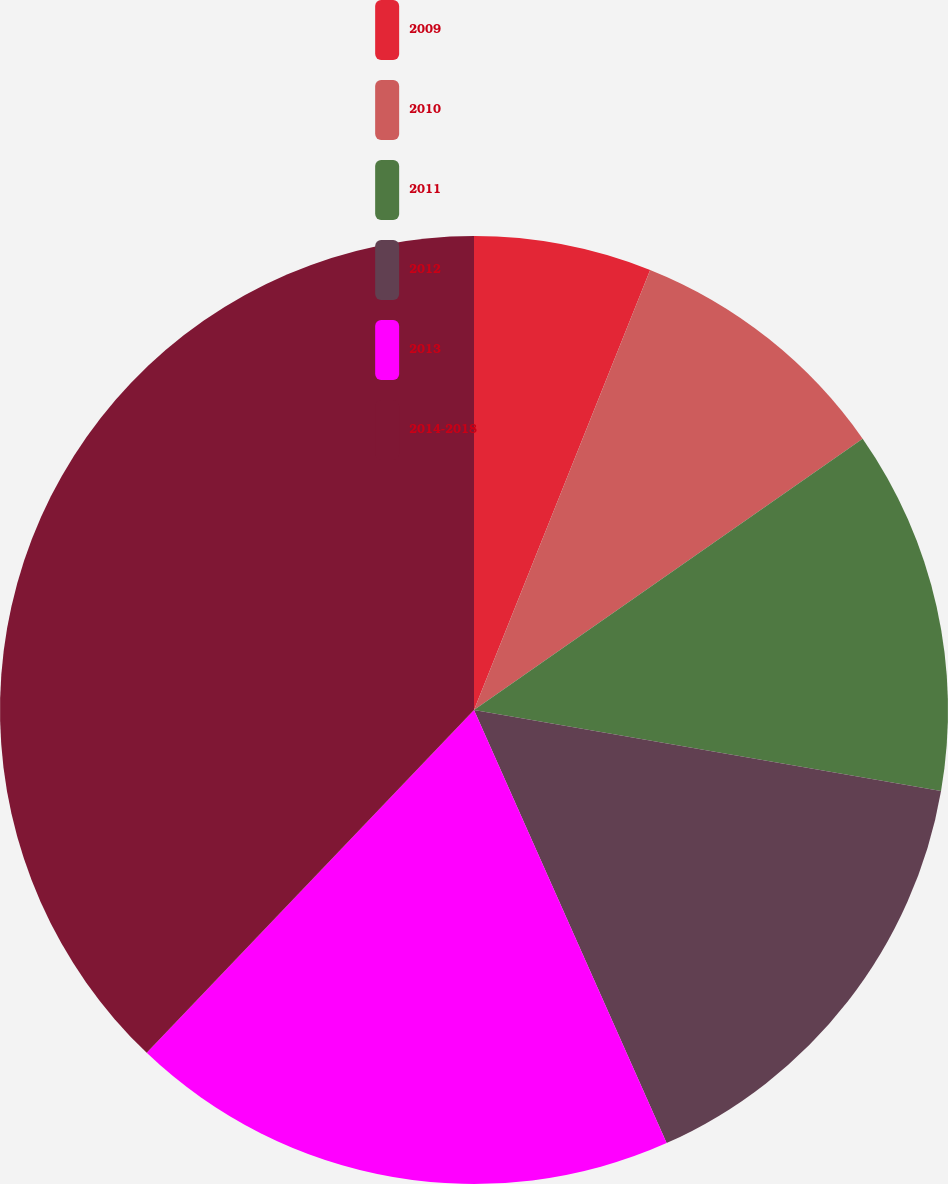Convert chart to OTSL. <chart><loc_0><loc_0><loc_500><loc_500><pie_chart><fcel>2009<fcel>2010<fcel>2011<fcel>2012<fcel>2013<fcel>2014-2018<nl><fcel>6.06%<fcel>9.24%<fcel>12.43%<fcel>15.61%<fcel>18.79%<fcel>37.87%<nl></chart> 